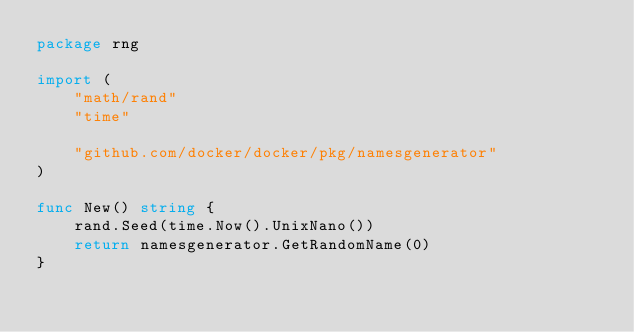<code> <loc_0><loc_0><loc_500><loc_500><_Go_>package rng

import (
	"math/rand"
	"time"

	"github.com/docker/docker/pkg/namesgenerator"
)

func New() string {
	rand.Seed(time.Now().UnixNano())
	return namesgenerator.GetRandomName(0)
}
</code> 